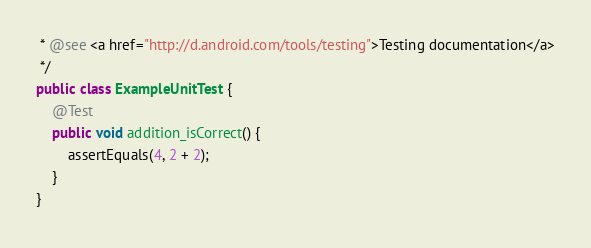<code> <loc_0><loc_0><loc_500><loc_500><_Java_> * @see <a href="http://d.android.com/tools/testing">Testing documentation</a>
 */
public class ExampleUnitTest {
    @Test
    public void addition_isCorrect() {
        assertEquals(4, 2 + 2);
    }
}</code> 